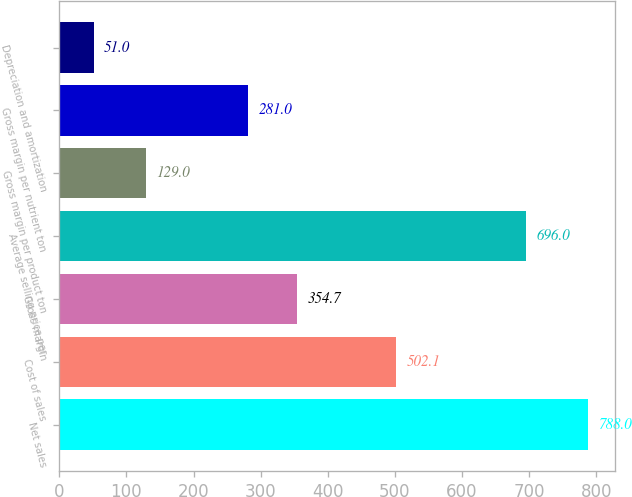Convert chart. <chart><loc_0><loc_0><loc_500><loc_500><bar_chart><fcel>Net sales<fcel>Cost of sales<fcel>Gross margin<fcel>Average selling price per<fcel>Gross margin per product ton<fcel>Gross margin per nutrient ton<fcel>Depreciation and amortization<nl><fcel>788<fcel>502.1<fcel>354.7<fcel>696<fcel>129<fcel>281<fcel>51<nl></chart> 